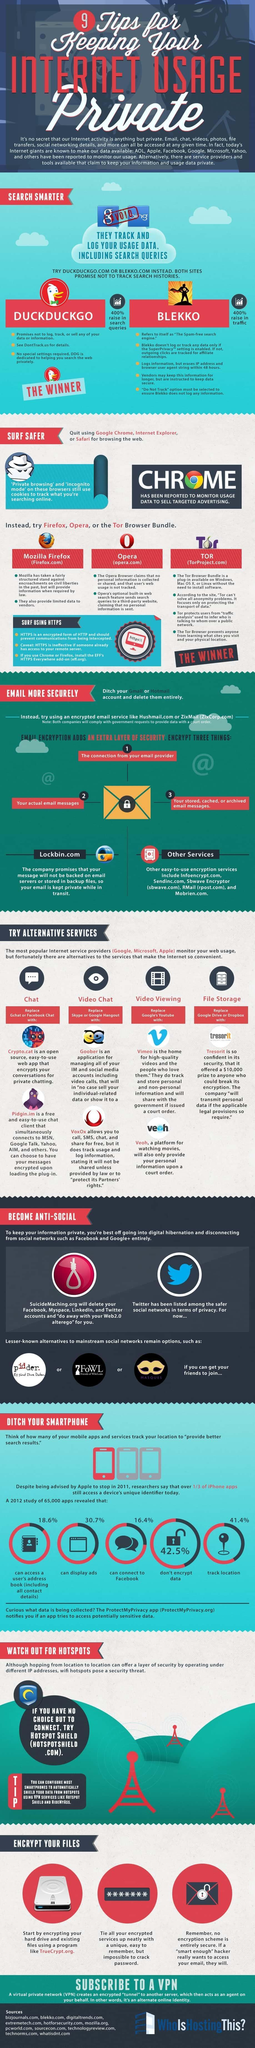Which is the best browser bundle between Opera, TOR, and Mozilla Firefox?
Answer the question with a short phrase. TOR Which two chats can be used to replace Gchat or facebook Chat? Cryto.cat, Pidgin.im Which of the following search engine can be used to surf safer, Safari, Google Chrome, or Mozilla Firefox? Mozilla Firefox Which of the following sites do not track user user data, Blekko, Google, DuckDuckGo, or Bing? Blekko, DuckDuckGo Which is a better platform for video chats, Skype, Goober or Google Hangout? Goober Which app provides better security for storing files Tresorit, Google Drive or Dropbox? Tresorit Which are two sites that track the search histories, Google, DuckDuckgo, Bing, or Blekko? Google, Bing 